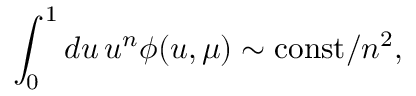Convert formula to latex. <formula><loc_0><loc_0><loc_500><loc_500>\int _ { 0 } ^ { 1 } d u \, u ^ { n } \phi ( u , \mu ) \sim c o n s t / n ^ { 2 } ,</formula> 